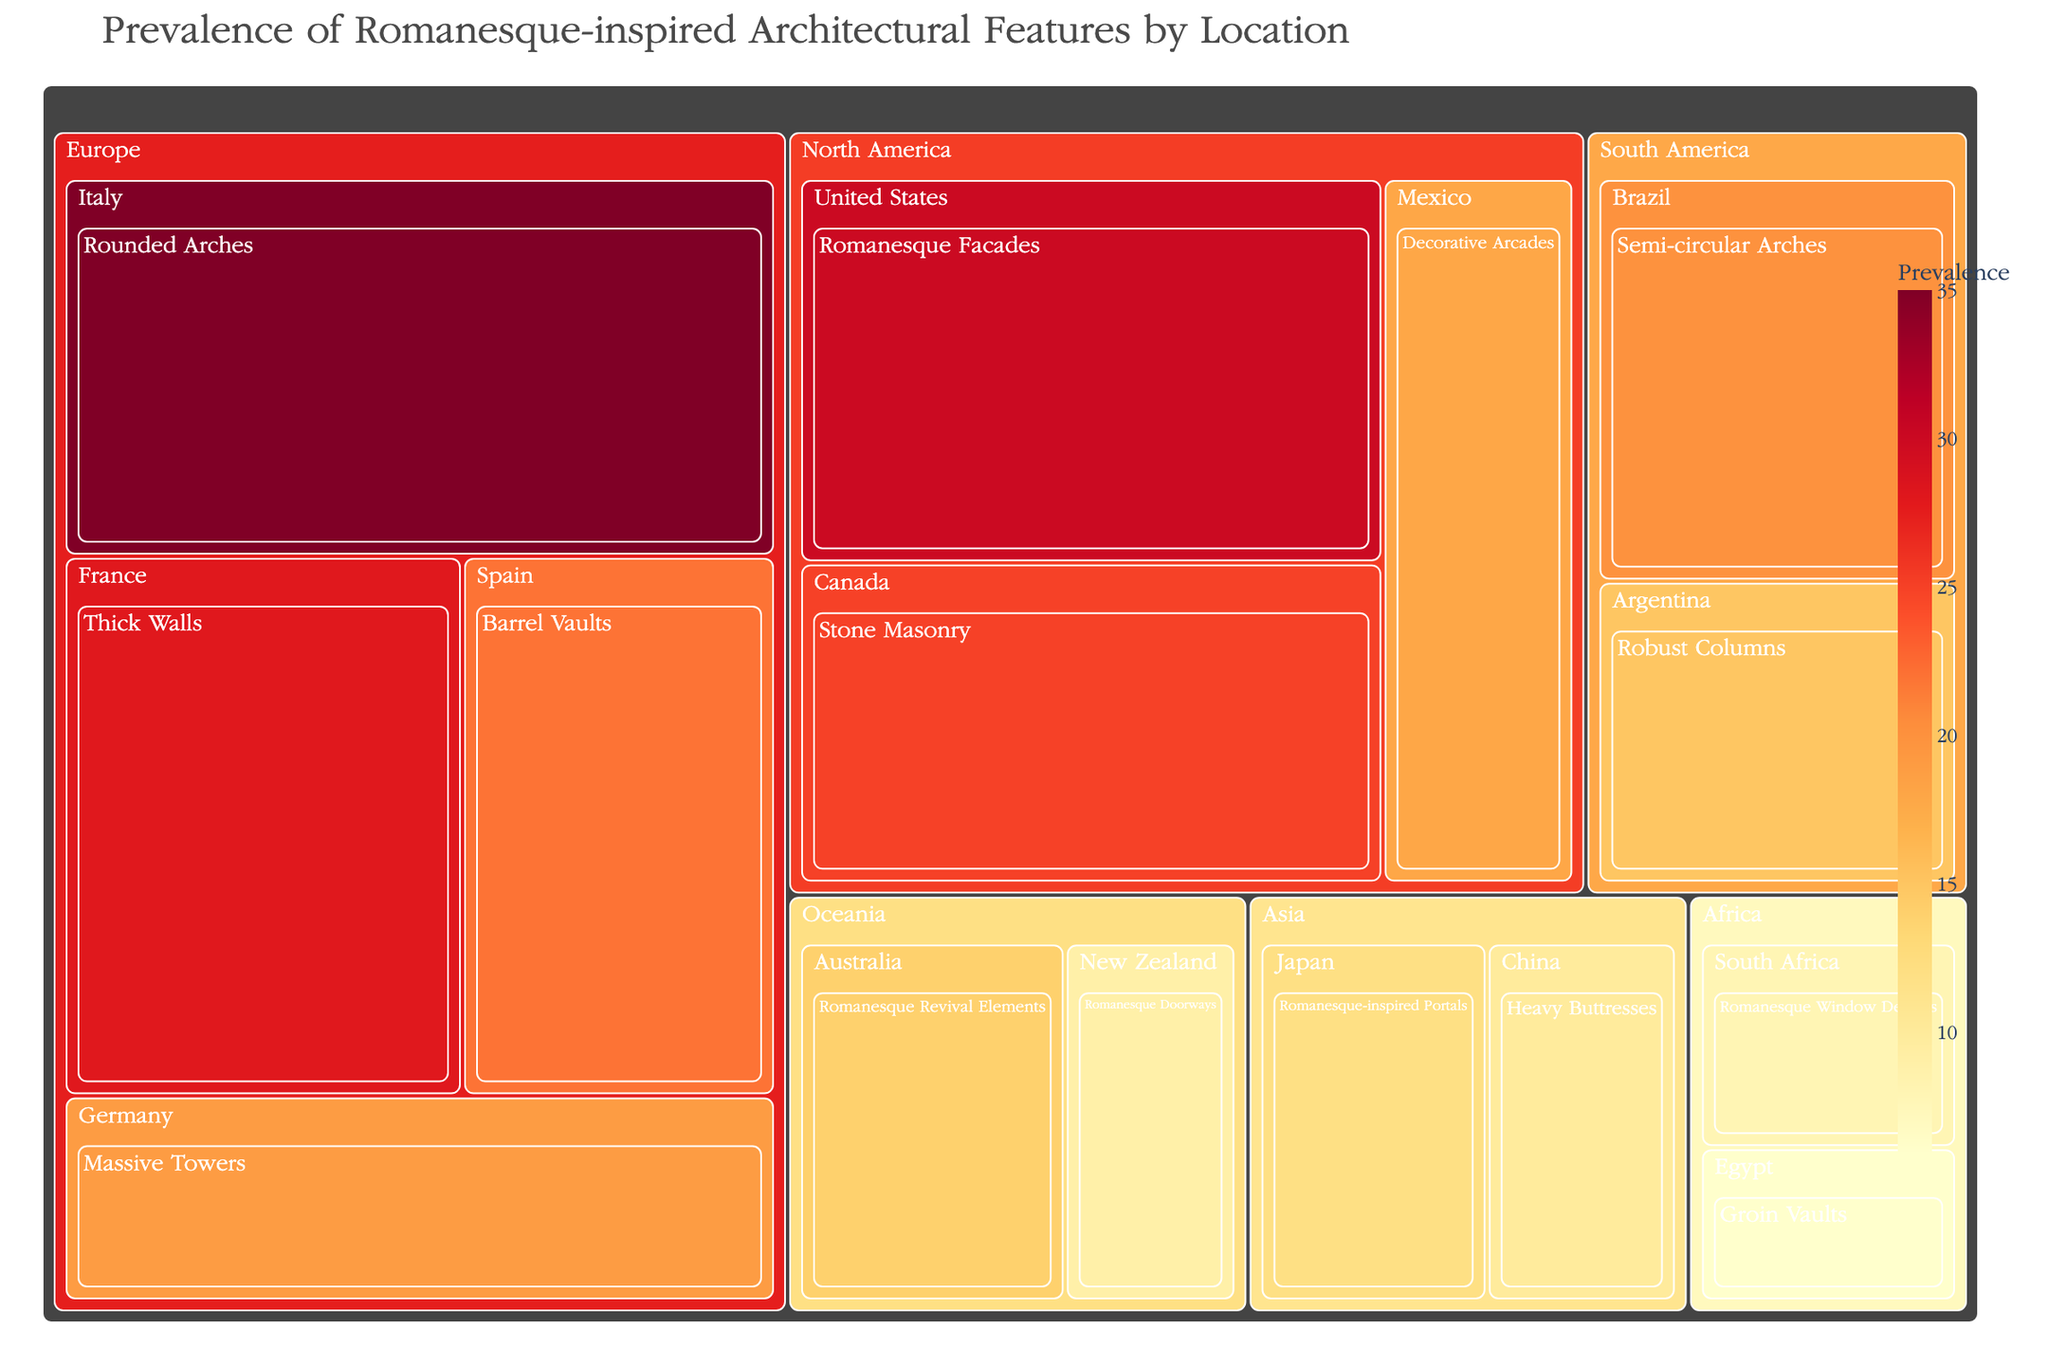What is the title of the treemap? The title of the treemap is displayed at the top of the figure. It summarizes the visual content of the figure.
Answer: Prevalence of Romanesque-inspired Architectural Features by Location Which continent has the highest prevalence for a single architectural feature? By visually inspecting the size and color of the tiles, you can identify the largest and darkest tile in the treemap, which represents the highest prevalence value.
Answer: Europe Which country in Europe features Rounded Arches? The treemap is hierarchically organized, so under Europe, look for the country labeled "Italy" which contains Rounded Arches.
Answer: Italy What is the total prevalence of Romanesque features in North America? Sum the prevalence values for the countries under North America: United States (30) + Canada (25) + Mexico (18). The total is 30 + 25 + 18 = 73.
Answer: 73 Compare the prevalence of Groin Vaults in Egypt to Romanesque Window Designs in South Africa. Which is higher? Locate the two countries in Africa in the treemap and compare the prevalence values. Egypt (6 for Groin Vaults) and South Africa (8 for Romanesque Window Designs).
Answer: South Africa What architectural feature has the highest prevalence in Australia? Navigate to the Oceania section, find Australia, and identify the feature with the corresponding prevalence value.
Answer: Romanesque Revival Elements Between Brazil and Argentina, which country has a higher prevalence of Romanesque-inspired features? Compare the values associated with Brazil (20) and Argentina (15) in the South America section of the treemap.
Answer: Brazil How many countries in Asia are included in this treemap? Count the countries listed under the Asia section. There are two countries: Japan and China.
Answer: 2 Calculate the total prevalence of architectural features in Oceania. Sum the prevalence values for Australia (14) and New Zealand (9). The total is 14 + 9 = 23.
Answer: 23 